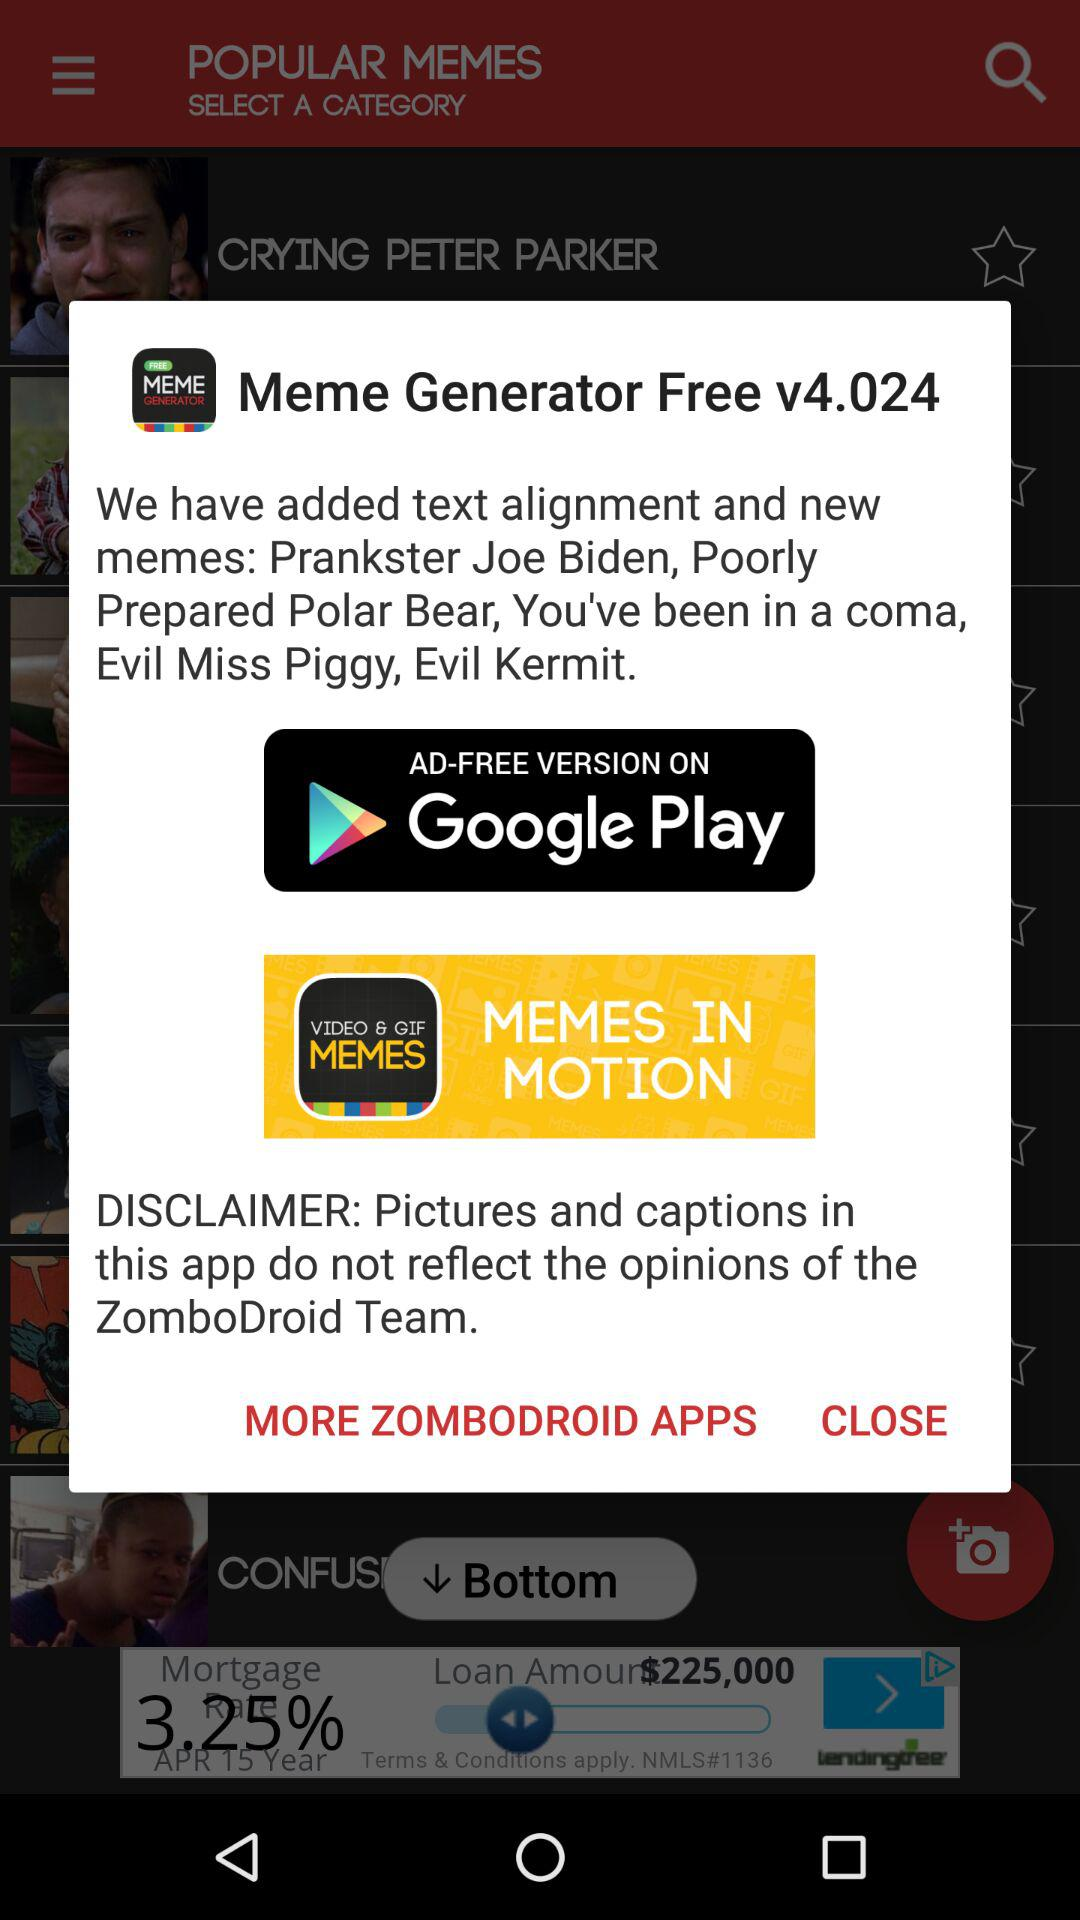What is the version? The version is v4.024. 